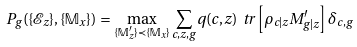<formula> <loc_0><loc_0><loc_500><loc_500>P _ { g } ( \{ \mathcal { E } _ { z } \} , \{ \mathbb { M } _ { x } \} ) = \max _ { \{ \mathbb { M } ^ { \prime } _ { z } \} \prec \{ \mathbb { M } _ { x } \} } \sum _ { c , z , g } q ( c , z ) \ t r \left [ \rho _ { c | z } M ^ { \prime } _ { g | z } \right ] \delta _ { c , g }</formula> 